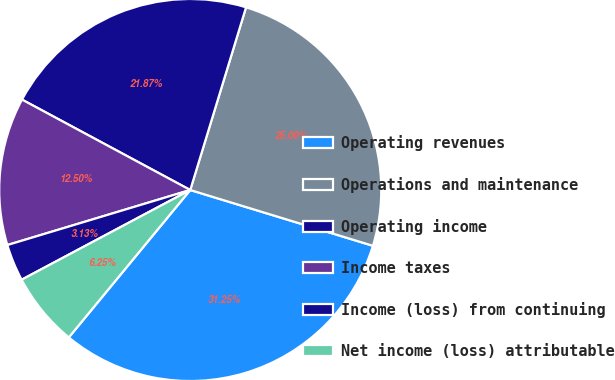Convert chart to OTSL. <chart><loc_0><loc_0><loc_500><loc_500><pie_chart><fcel>Operating revenues<fcel>Operations and maintenance<fcel>Operating income<fcel>Income taxes<fcel>Income (loss) from continuing<fcel>Net income (loss) attributable<nl><fcel>31.25%<fcel>25.0%<fcel>21.87%<fcel>12.5%<fcel>3.13%<fcel>6.25%<nl></chart> 